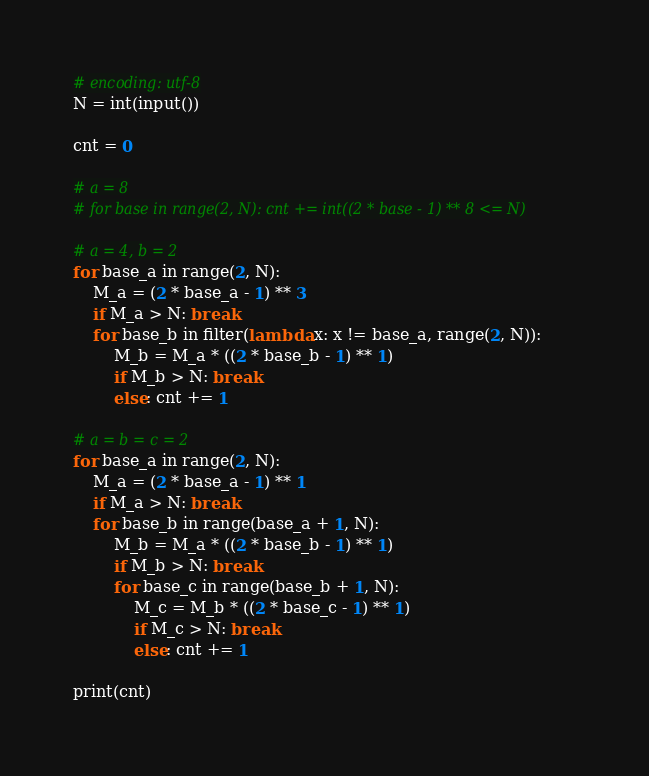Convert code to text. <code><loc_0><loc_0><loc_500><loc_500><_Python_># encoding: utf-8
N = int(input())

cnt = 0

# a = 8
# for base in range(2, N): cnt += int((2 * base - 1) ** 8 <= N)

# a = 4, b = 2
for base_a in range(2, N):
    M_a = (2 * base_a - 1) ** 3
    if M_a > N: break
    for base_b in filter(lambda x: x != base_a, range(2, N)):
        M_b = M_a * ((2 * base_b - 1) ** 1)
        if M_b > N: break
        else: cnt += 1
        
# a = b = c = 2
for base_a in range(2, N):
    M_a = (2 * base_a - 1) ** 1
    if M_a > N: break
    for base_b in range(base_a + 1, N):
        M_b = M_a * ((2 * base_b - 1) ** 1)
        if M_b > N: break
        for base_c in range(base_b + 1, N):
            M_c = M_b * ((2 * base_c - 1) ** 1)
            if M_c > N: break
            else: cnt += 1

print(cnt)</code> 